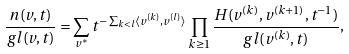Convert formula to latex. <formula><loc_0><loc_0><loc_500><loc_500>\frac { n ( v , t ) } { g l ( v , t ) } = \sum _ { v ^ { * } } t ^ { - \sum _ { k < l } \langle v ^ { ( k ) } , v ^ { ( l ) } \rangle } \prod _ { k \geq 1 } \frac { H ( v ^ { ( k ) } , v ^ { ( k + 1 ) } , t ^ { - 1 } ) } { g l ( v ^ { ( k ) } , t ) } ,</formula> 